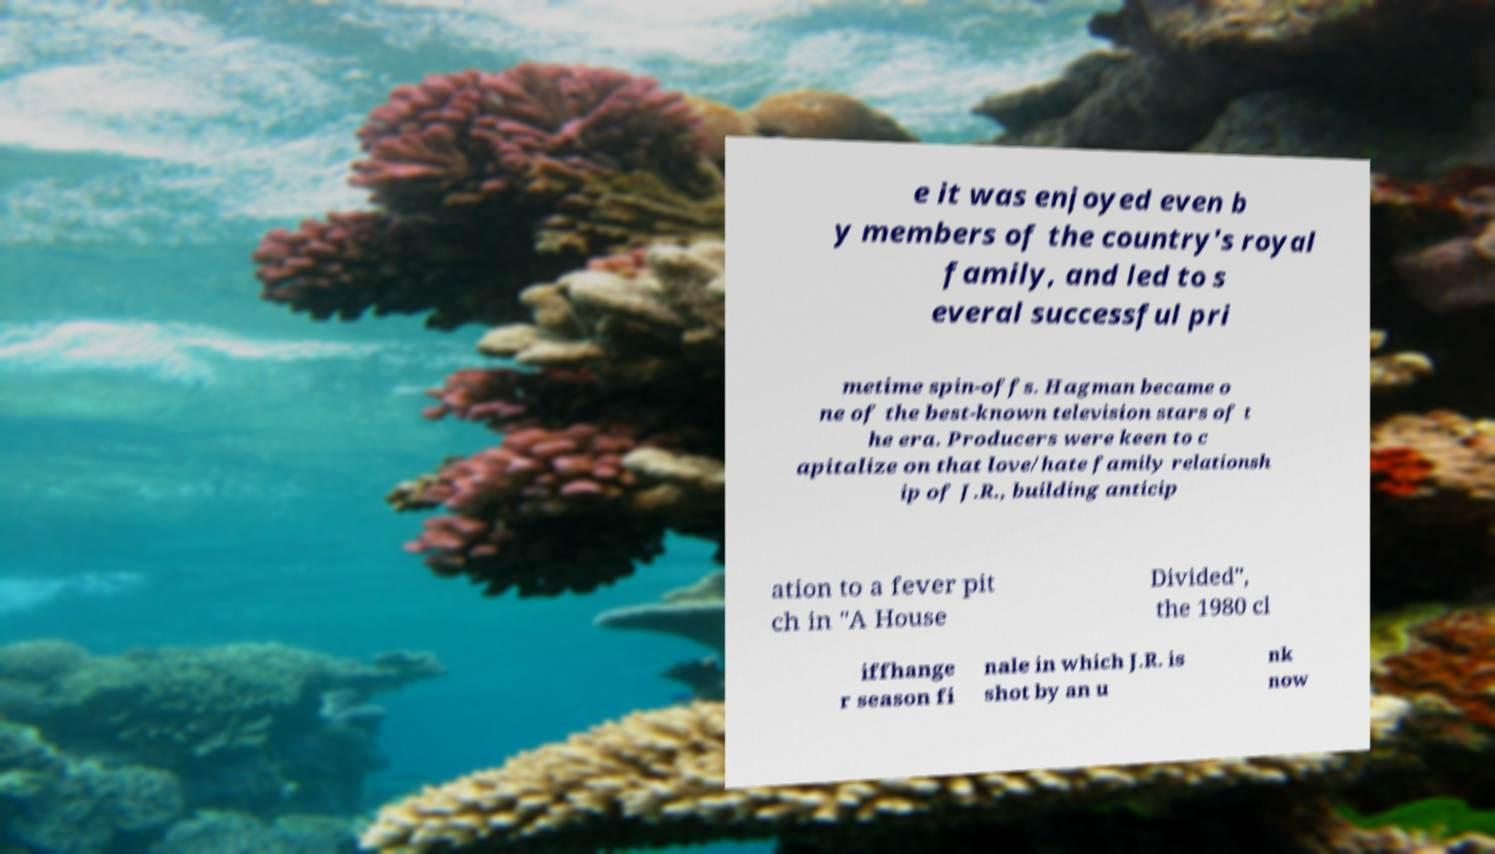What messages or text are displayed in this image? I need them in a readable, typed format. e it was enjoyed even b y members of the country's royal family, and led to s everal successful pri metime spin-offs. Hagman became o ne of the best-known television stars of t he era. Producers were keen to c apitalize on that love/hate family relationsh ip of J.R., building anticip ation to a fever pit ch in "A House Divided", the 1980 cl iffhange r season fi nale in which J.R. is shot by an u nk now 